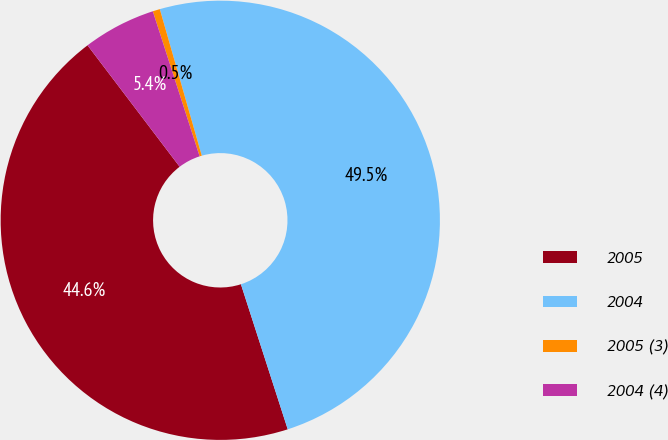Convert chart to OTSL. <chart><loc_0><loc_0><loc_500><loc_500><pie_chart><fcel>2005<fcel>2004<fcel>2005 (3)<fcel>2004 (4)<nl><fcel>44.64%<fcel>49.47%<fcel>0.53%<fcel>5.36%<nl></chart> 